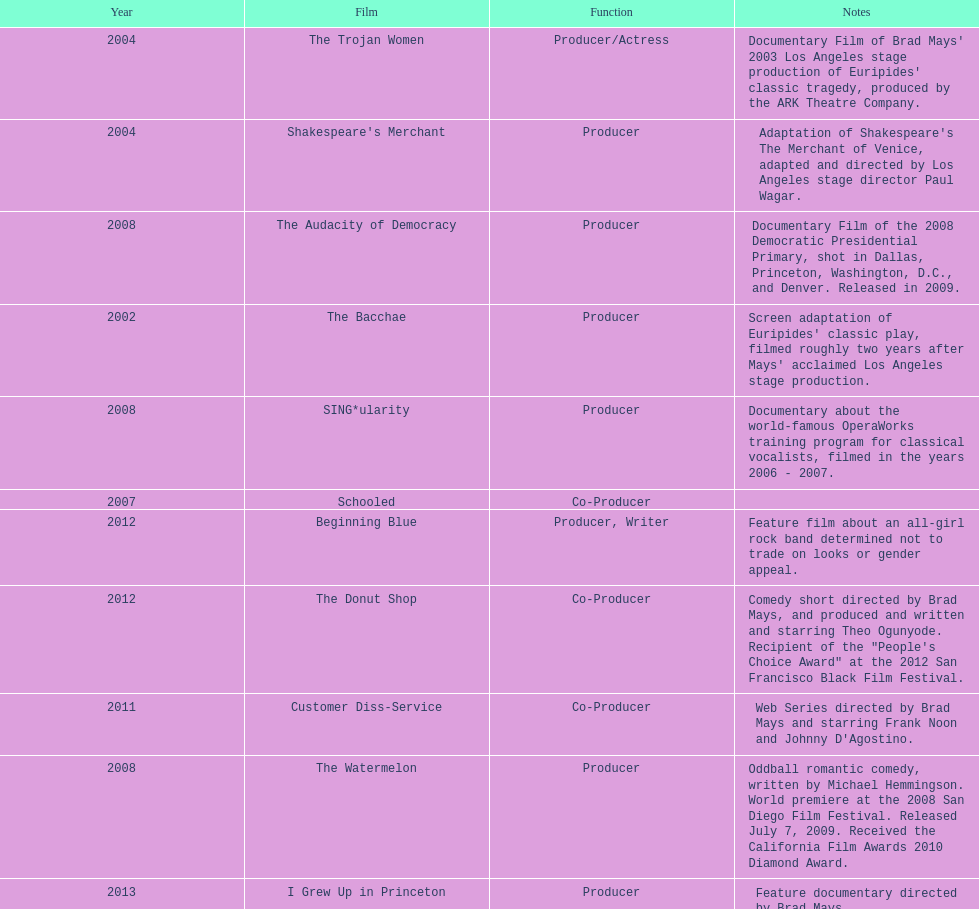How long was the film schooled out before beginning blue? 5 years. 